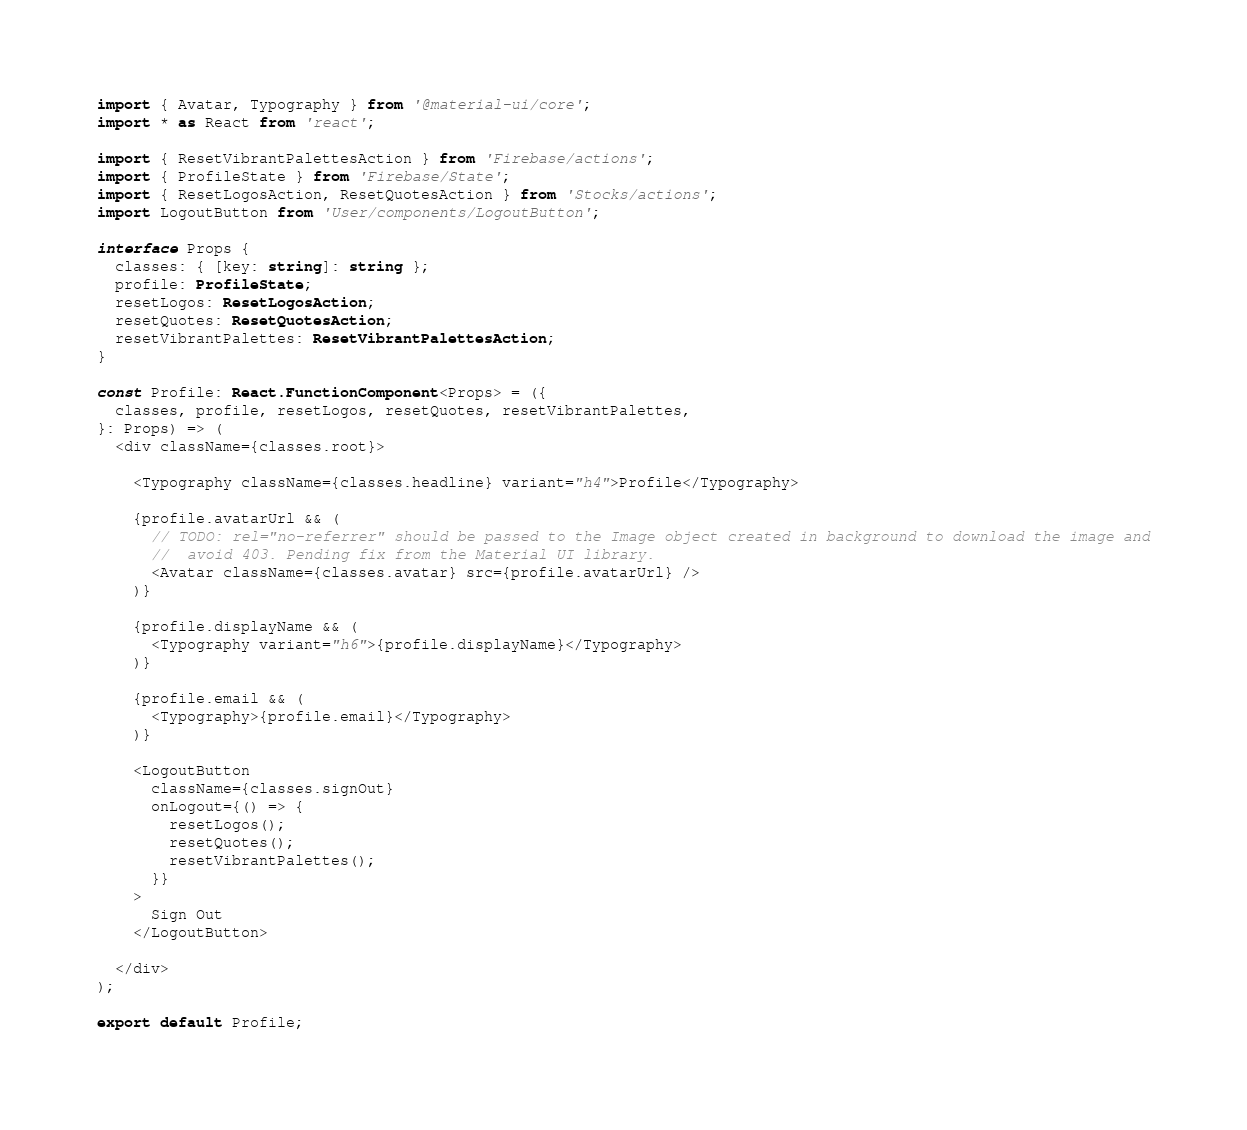<code> <loc_0><loc_0><loc_500><loc_500><_TypeScript_>import { Avatar, Typography } from '@material-ui/core';
import * as React from 'react';

import { ResetVibrantPalettesAction } from 'Firebase/actions';
import { ProfileState } from 'Firebase/State';
import { ResetLogosAction, ResetQuotesAction } from 'Stocks/actions';
import LogoutButton from 'User/components/LogoutButton';

interface Props {
  classes: { [key: string]: string };
  profile: ProfileState;
  resetLogos: ResetLogosAction;
  resetQuotes: ResetQuotesAction;
  resetVibrantPalettes: ResetVibrantPalettesAction;
}

const Profile: React.FunctionComponent<Props> = ({
  classes, profile, resetLogos, resetQuotes, resetVibrantPalettes,
}: Props) => (
  <div className={classes.root}>

    <Typography className={classes.headline} variant="h4">Profile</Typography>

    {profile.avatarUrl && (
      // TODO: rel="no-referrer" should be passed to the Image object created in background to download the image and
      //  avoid 403. Pending fix from the Material UI library.
      <Avatar className={classes.avatar} src={profile.avatarUrl} />
    )}

    {profile.displayName && (
      <Typography variant="h6">{profile.displayName}</Typography>
    )}

    {profile.email && (
      <Typography>{profile.email}</Typography>
    )}

    <LogoutButton
      className={classes.signOut}
      onLogout={() => {
        resetLogos();
        resetQuotes();
        resetVibrantPalettes();
      }}
    >
      Sign Out
    </LogoutButton>

  </div>
);

export default Profile;
</code> 